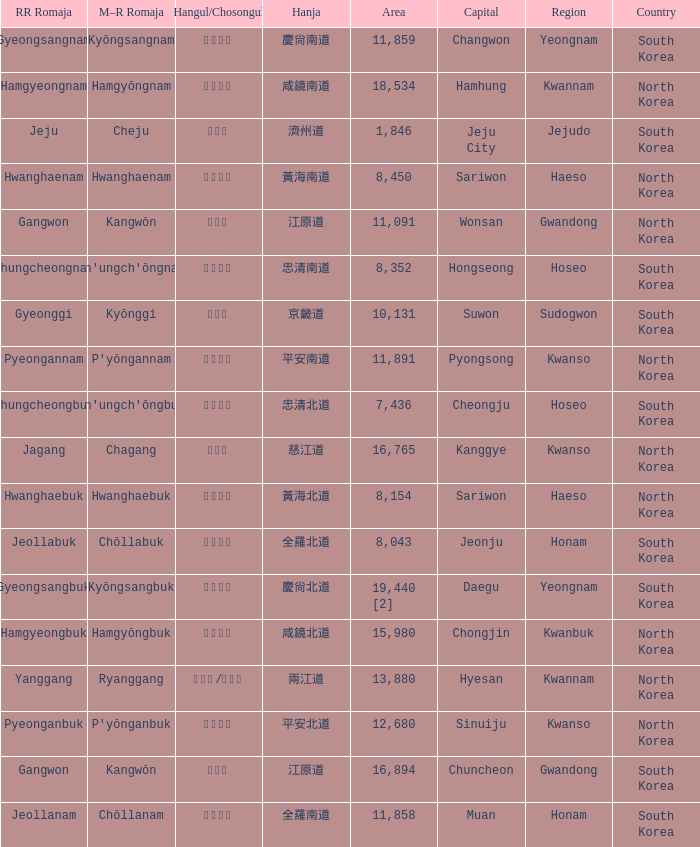What is the RR Romaja for the province that has Hangul of 강원도 and capital of Wonsan? Gangwon. 